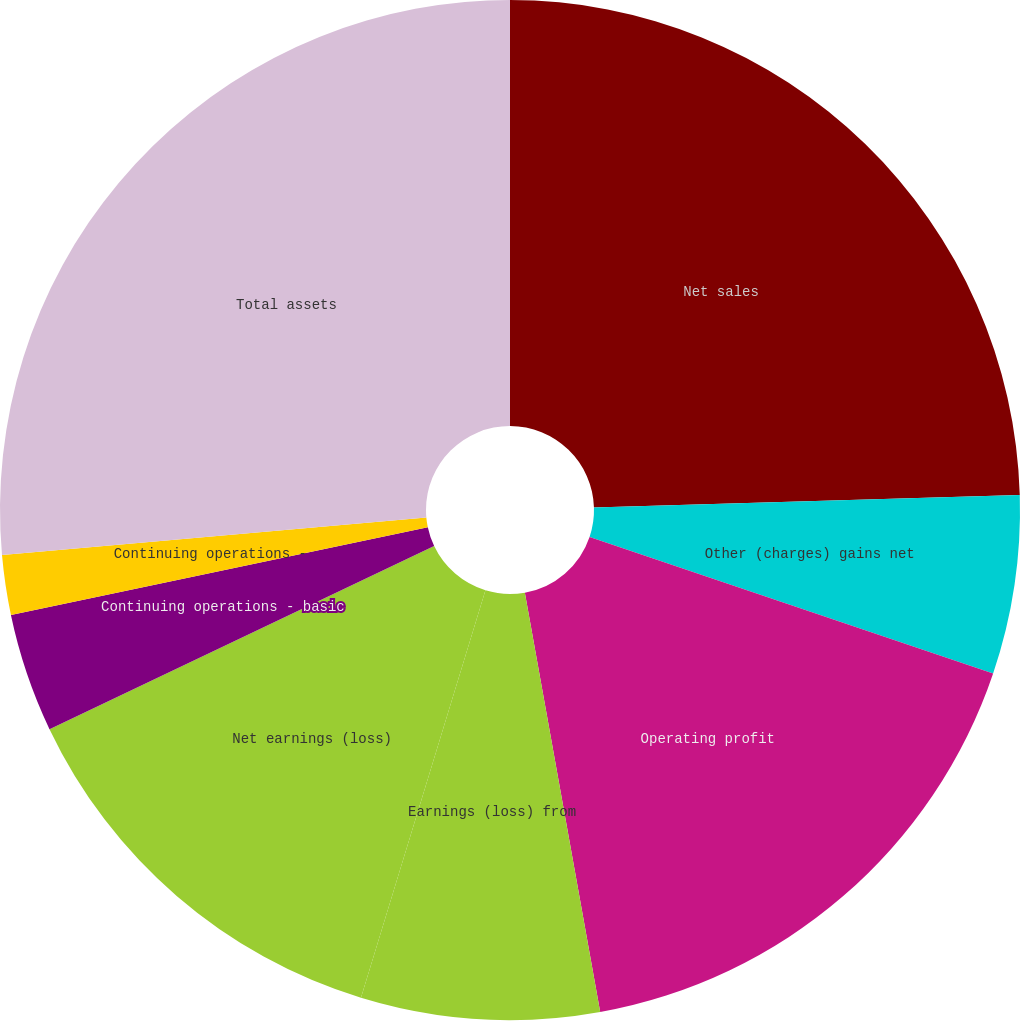Convert chart. <chart><loc_0><loc_0><loc_500><loc_500><pie_chart><fcel>Net sales<fcel>Other (charges) gains net<fcel>Operating profit<fcel>Earnings (loss) from<fcel>Net earnings (loss)<fcel>Continuing operations - basic<fcel>Continuing operations -<fcel>Total assets<nl><fcel>24.53%<fcel>5.66%<fcel>16.98%<fcel>7.55%<fcel>13.21%<fcel>3.77%<fcel>1.89%<fcel>26.41%<nl></chart> 